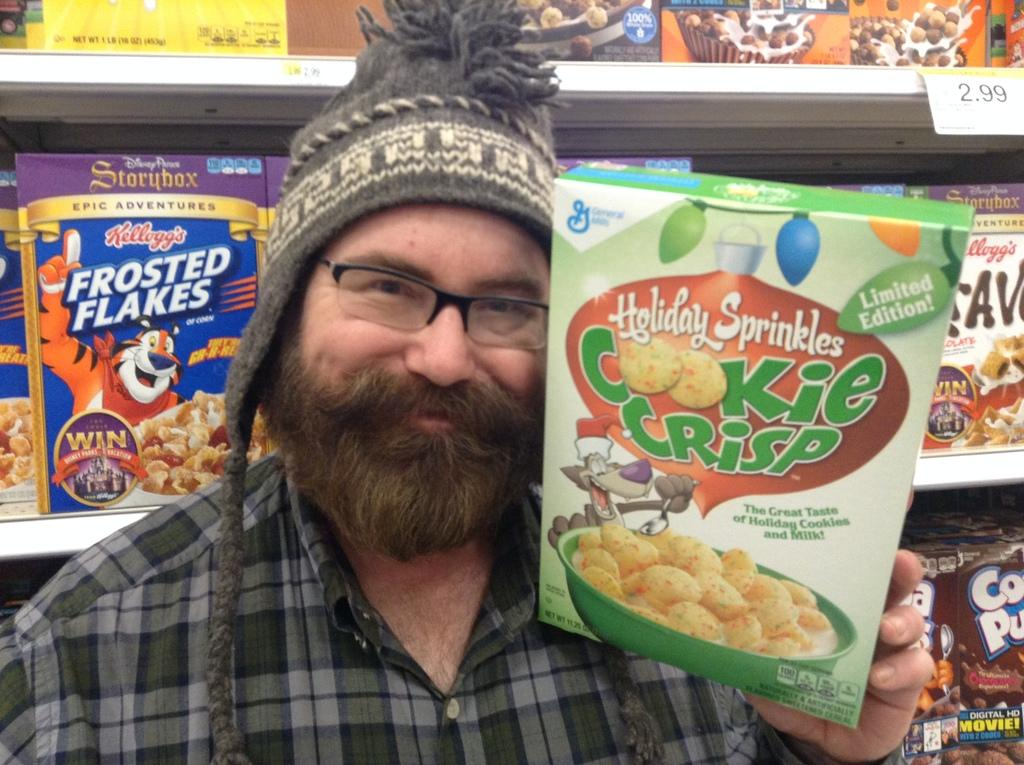What can be seen in the image? There is a person in the image. Can you describe the person's appearance? The person is wearing specs and a cap. What is the person holding in the image? The person is holding a packet. What is visible in the background of the image? There are racks with packets in the background of the image. What can be observed about the packets? The packets have names and images on them. What type of beam is supporting the person in the image? There is no beam present in the image, and the person is not being supported by any beam. 